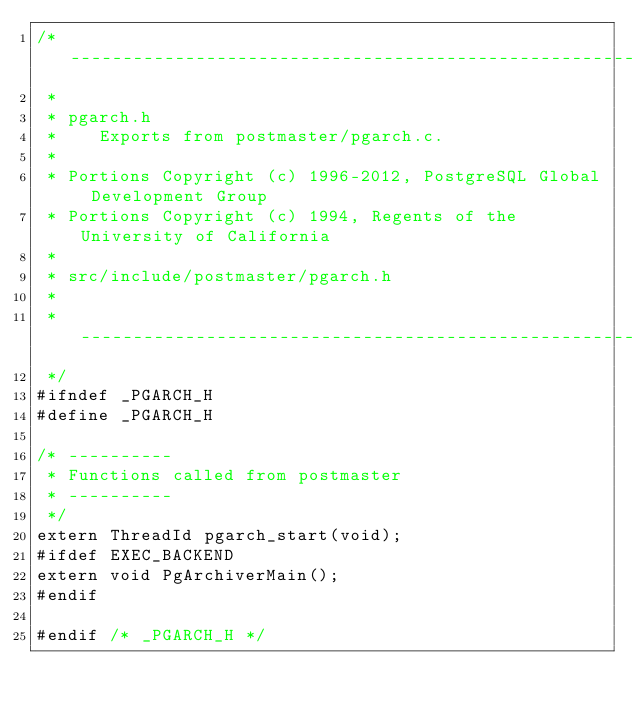<code> <loc_0><loc_0><loc_500><loc_500><_C_>/* -------------------------------------------------------------------------
 *
 * pgarch.h
 *	  Exports from postmaster/pgarch.c.
 *
 * Portions Copyright (c) 1996-2012, PostgreSQL Global Development Group
 * Portions Copyright (c) 1994, Regents of the University of California
 *
 * src/include/postmaster/pgarch.h
 *
 * -------------------------------------------------------------------------
 */
#ifndef _PGARCH_H
#define _PGARCH_H

/* ----------
 * Functions called from postmaster
 * ----------
 */
extern ThreadId pgarch_start(void);
#ifdef EXEC_BACKEND
extern void PgArchiverMain();
#endif

#endif /* _PGARCH_H */
</code> 